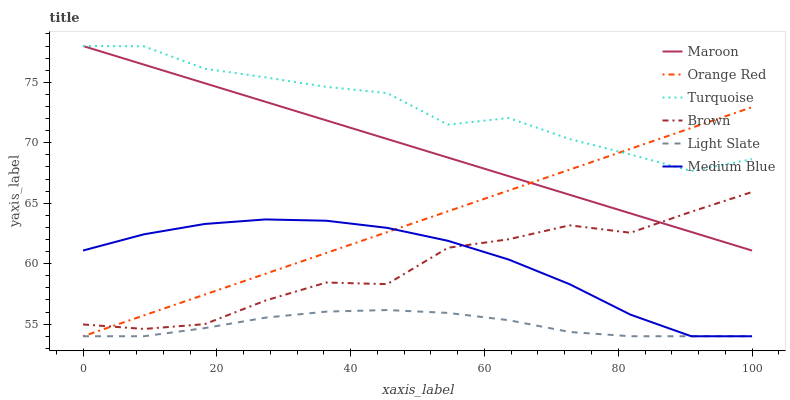Does Light Slate have the minimum area under the curve?
Answer yes or no. Yes. Does Turquoise have the maximum area under the curve?
Answer yes or no. Yes. Does Turquoise have the minimum area under the curve?
Answer yes or no. No. Does Light Slate have the maximum area under the curve?
Answer yes or no. No. Is Orange Red the smoothest?
Answer yes or no. Yes. Is Brown the roughest?
Answer yes or no. Yes. Is Turquoise the smoothest?
Answer yes or no. No. Is Turquoise the roughest?
Answer yes or no. No. Does Light Slate have the lowest value?
Answer yes or no. Yes. Does Turquoise have the lowest value?
Answer yes or no. No. Does Maroon have the highest value?
Answer yes or no. Yes. Does Light Slate have the highest value?
Answer yes or no. No. Is Light Slate less than Turquoise?
Answer yes or no. Yes. Is Brown greater than Light Slate?
Answer yes or no. Yes. Does Brown intersect Orange Red?
Answer yes or no. Yes. Is Brown less than Orange Red?
Answer yes or no. No. Is Brown greater than Orange Red?
Answer yes or no. No. Does Light Slate intersect Turquoise?
Answer yes or no. No. 